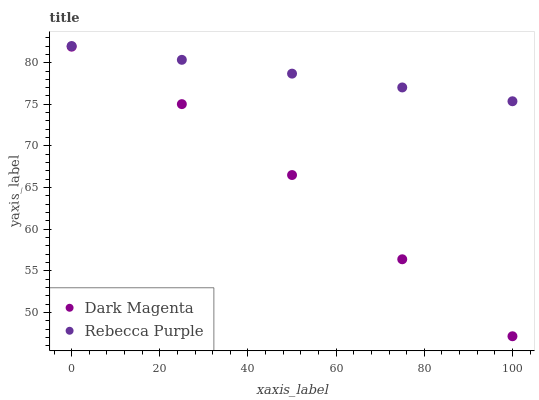Does Dark Magenta have the minimum area under the curve?
Answer yes or no. Yes. Does Rebecca Purple have the maximum area under the curve?
Answer yes or no. Yes. Does Rebecca Purple have the minimum area under the curve?
Answer yes or no. No. Is Rebecca Purple the smoothest?
Answer yes or no. Yes. Is Dark Magenta the roughest?
Answer yes or no. Yes. Is Rebecca Purple the roughest?
Answer yes or no. No. Does Dark Magenta have the lowest value?
Answer yes or no. Yes. Does Rebecca Purple have the lowest value?
Answer yes or no. No. Does Rebecca Purple have the highest value?
Answer yes or no. Yes. Is Dark Magenta less than Rebecca Purple?
Answer yes or no. Yes. Is Rebecca Purple greater than Dark Magenta?
Answer yes or no. Yes. Does Dark Magenta intersect Rebecca Purple?
Answer yes or no. No. 